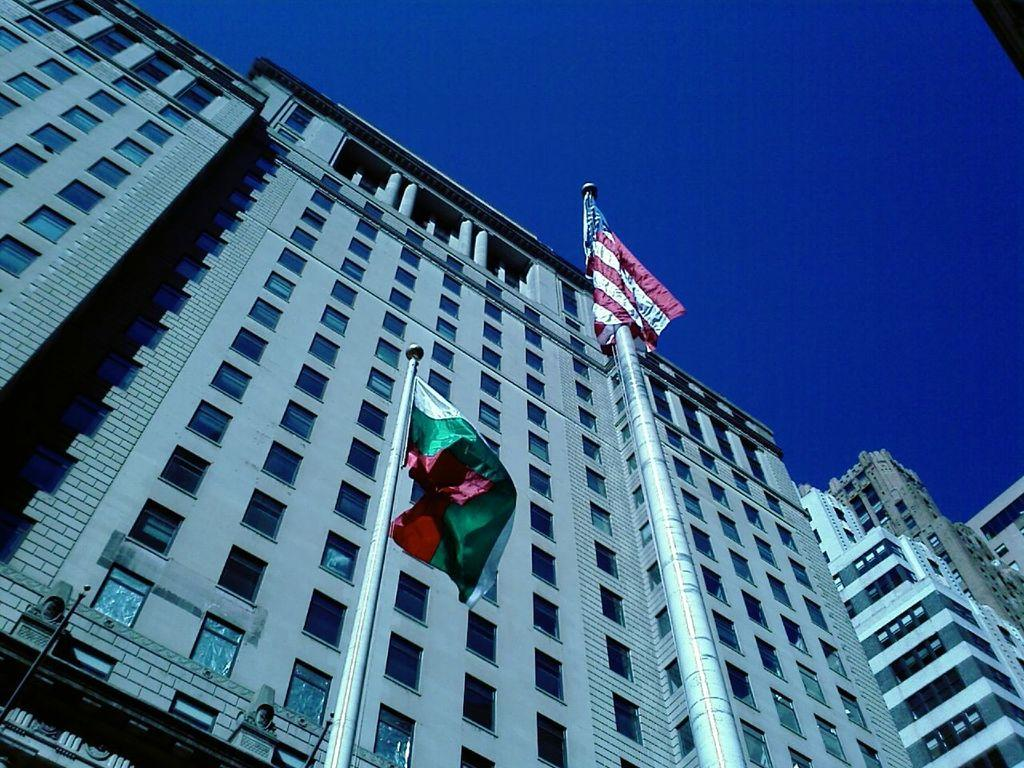What type of structures are depicted in the image? There are huge buildings in the image. What feature is prominent on the buildings? The buildings have plenty of windows. Are there any additional elements in front of one of the buildings? Yes, there are two flags in front of one of the buildings. How many children can be seen playing near the door in the image? There is no door or children present in the image; it features huge buildings with windows and two flags in front of one of them. 